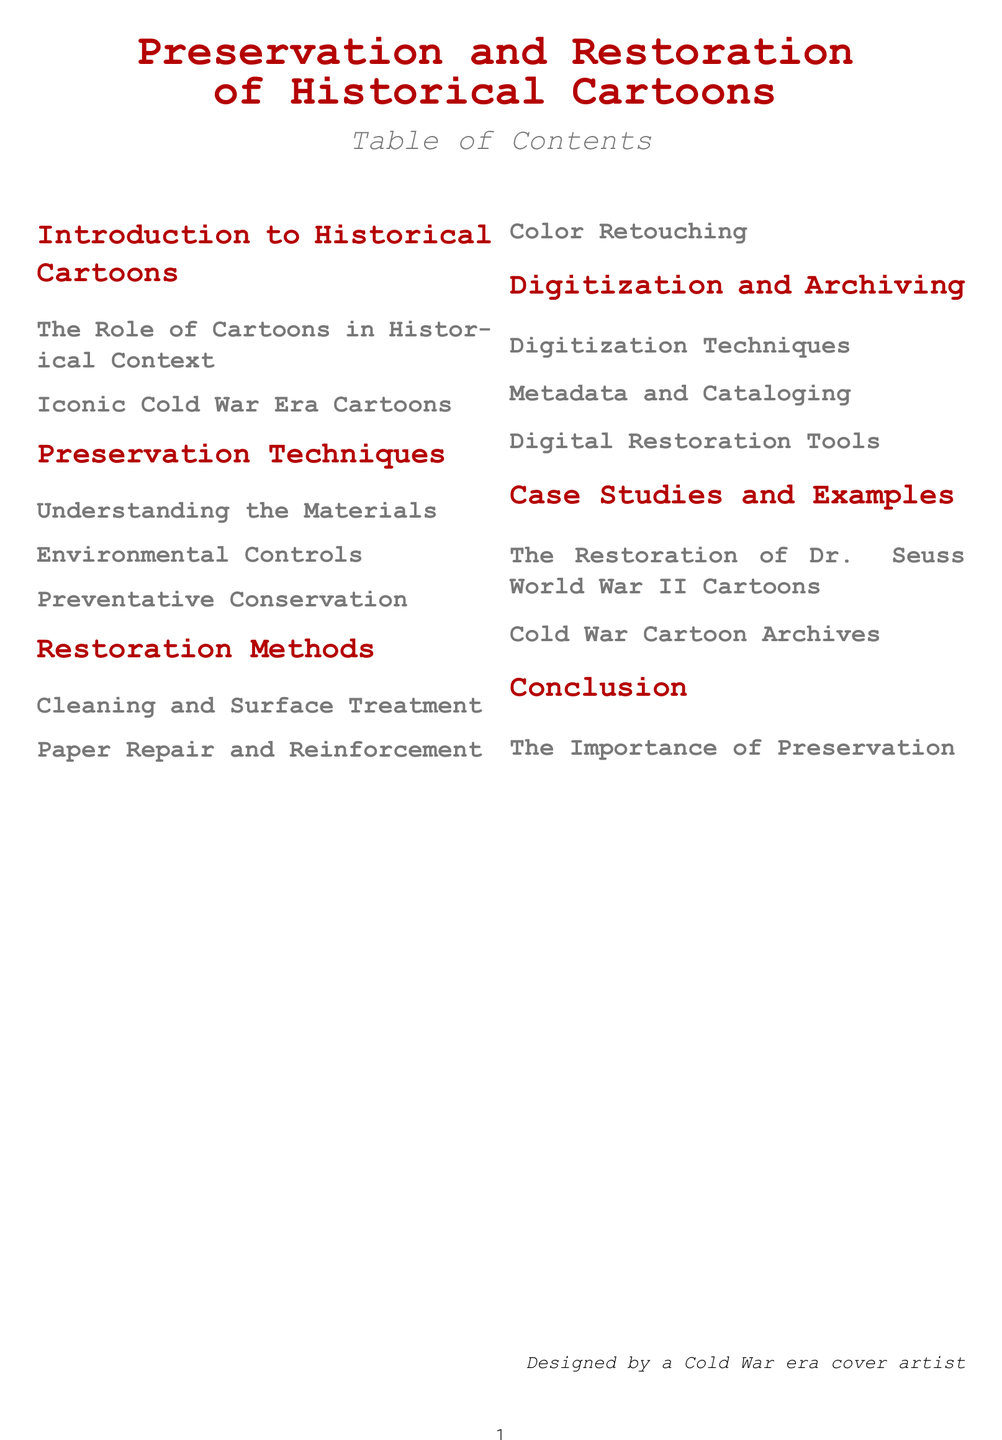What is the title of the document? The title is displayed prominently at the top of the document and identifies the main theme.
Answer: Preservation and Restoration of Historical Cartoons How many sections are in the Table of Contents? The number of sections can be counted from the main headings in the Table of Contents.
Answer: 6 What is the subtitle of the document? The subtitle provides additional context about the content and is listed under the main title.
Answer: of Historical Cartoons What is the focus of the first section? The title of the first section indicates what it will discuss relating to cartoons.
Answer: Introduction to Historical Cartoons Which restoration method involves color adjustments? The relevant subsection discusses the techniques for restoring colors in historical cartoons.
Answer: Color Retouching What is the last subsection in the document? The last subsection is listed under the Conclusion section and summarizes the document's importance.
Answer: The Importance of Preservation How many subsections are under Preservation Techniques? The count can be determined by listing the subsections in that section.
Answer: 3 What iconic era is referenced in the document? This specifically refers to a historical period mentioned in the Table of Contents.
Answer: Cold War What is one example of a case study mentioned? This asks for a specific case study listed in the Table of Contents under examples.
Answer: The Restoration of Dr. Seuss World War II Cartoons 